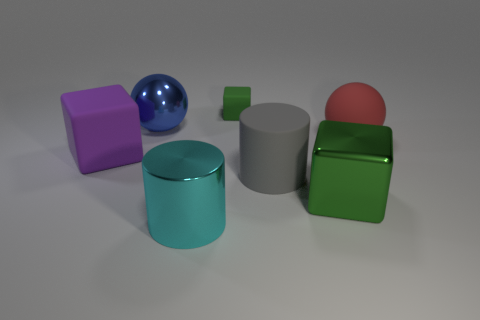Is there any other thing that has the same size as the green rubber block?
Provide a succinct answer. No. What size is the other cube that is made of the same material as the small cube?
Your answer should be compact. Large. Is the shape of the tiny green rubber object the same as the large matte object that is to the left of the cyan metal thing?
Keep it short and to the point. Yes. What size is the green shiny cube?
Provide a succinct answer. Large. Is the number of large gray things behind the rubber cylinder less than the number of large gray cubes?
Your response must be concise. No. How many purple rubber things have the same size as the blue shiny ball?
Your answer should be very brief. 1. What shape is the shiny thing that is the same color as the tiny matte object?
Provide a short and direct response. Cube. There is a rubber block behind the large purple cube; is it the same color as the big block left of the big gray cylinder?
Provide a short and direct response. No. There is a green shiny block; how many large green metal cubes are right of it?
Offer a terse response. 0. What is the size of the shiny block that is the same color as the tiny rubber thing?
Provide a succinct answer. Large. 